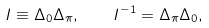Convert formula to latex. <formula><loc_0><loc_0><loc_500><loc_500>I \equiv \Delta _ { 0 } \Delta _ { \pi } , \quad I ^ { - 1 } = \Delta _ { \pi } \Delta _ { 0 } ,</formula> 